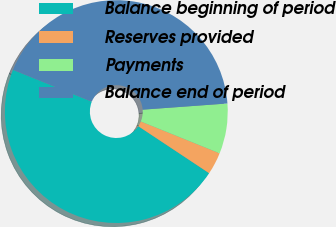Convert chart to OTSL. <chart><loc_0><loc_0><loc_500><loc_500><pie_chart><fcel>Balance beginning of period<fcel>Reserves provided<fcel>Payments<fcel>Balance end of period<nl><fcel>46.79%<fcel>3.21%<fcel>7.27%<fcel>42.73%<nl></chart> 